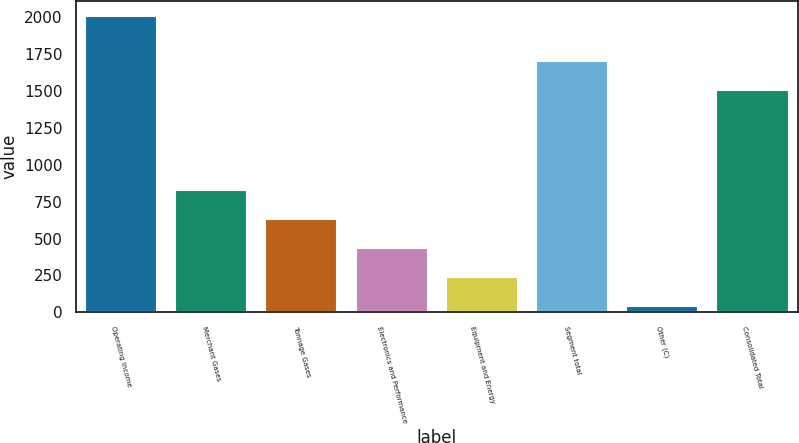<chart> <loc_0><loc_0><loc_500><loc_500><bar_chart><fcel>Operating Income<fcel>Merchant Gases<fcel>Tonnage Gases<fcel>Electronics and Performance<fcel>Equipment and Energy<fcel>Segment total<fcel>Other (C)<fcel>Consolidated Total<nl><fcel>2011<fcel>827.98<fcel>630.81<fcel>433.64<fcel>236.47<fcel>1705.27<fcel>39.3<fcel>1508.1<nl></chart> 